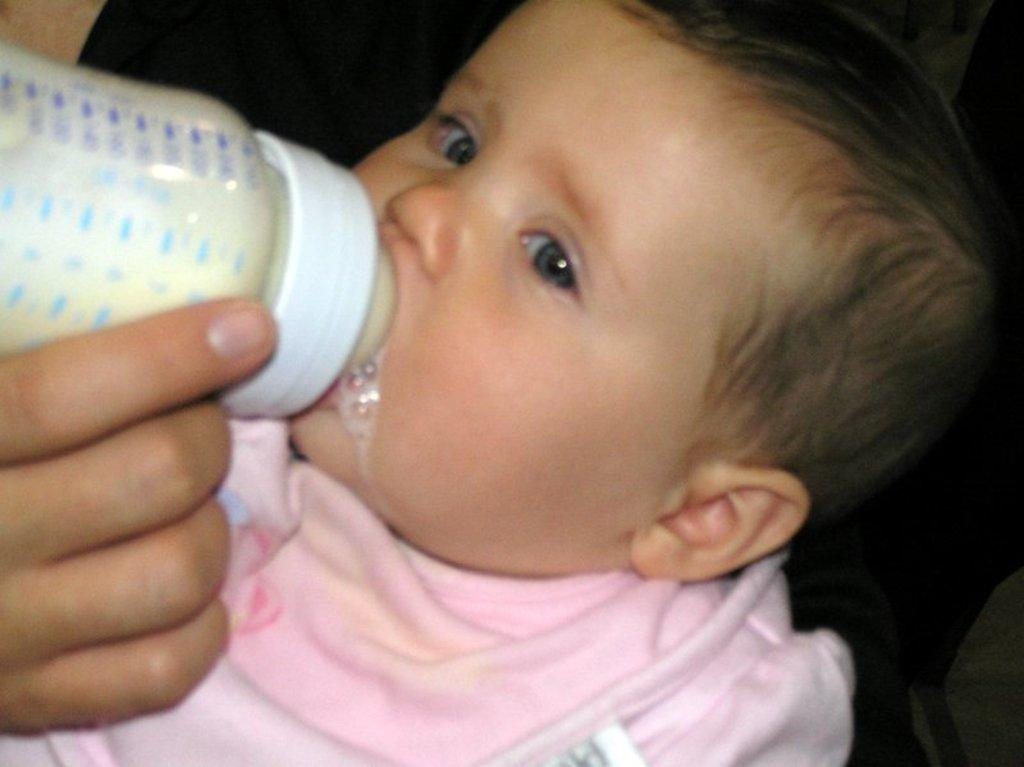What is the main subject of the image? There is a child in the image. What is the child holding in the image? There is a milk bottle in the image. Whose hand is visible in the image? A person's hand is visible in the image. What type of leaf is being used as a part of the horse's saddle in the image? There is no leaf, horse, or saddle present in the image. 